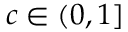Convert formula to latex. <formula><loc_0><loc_0><loc_500><loc_500>c \in ( 0 , 1 ]</formula> 